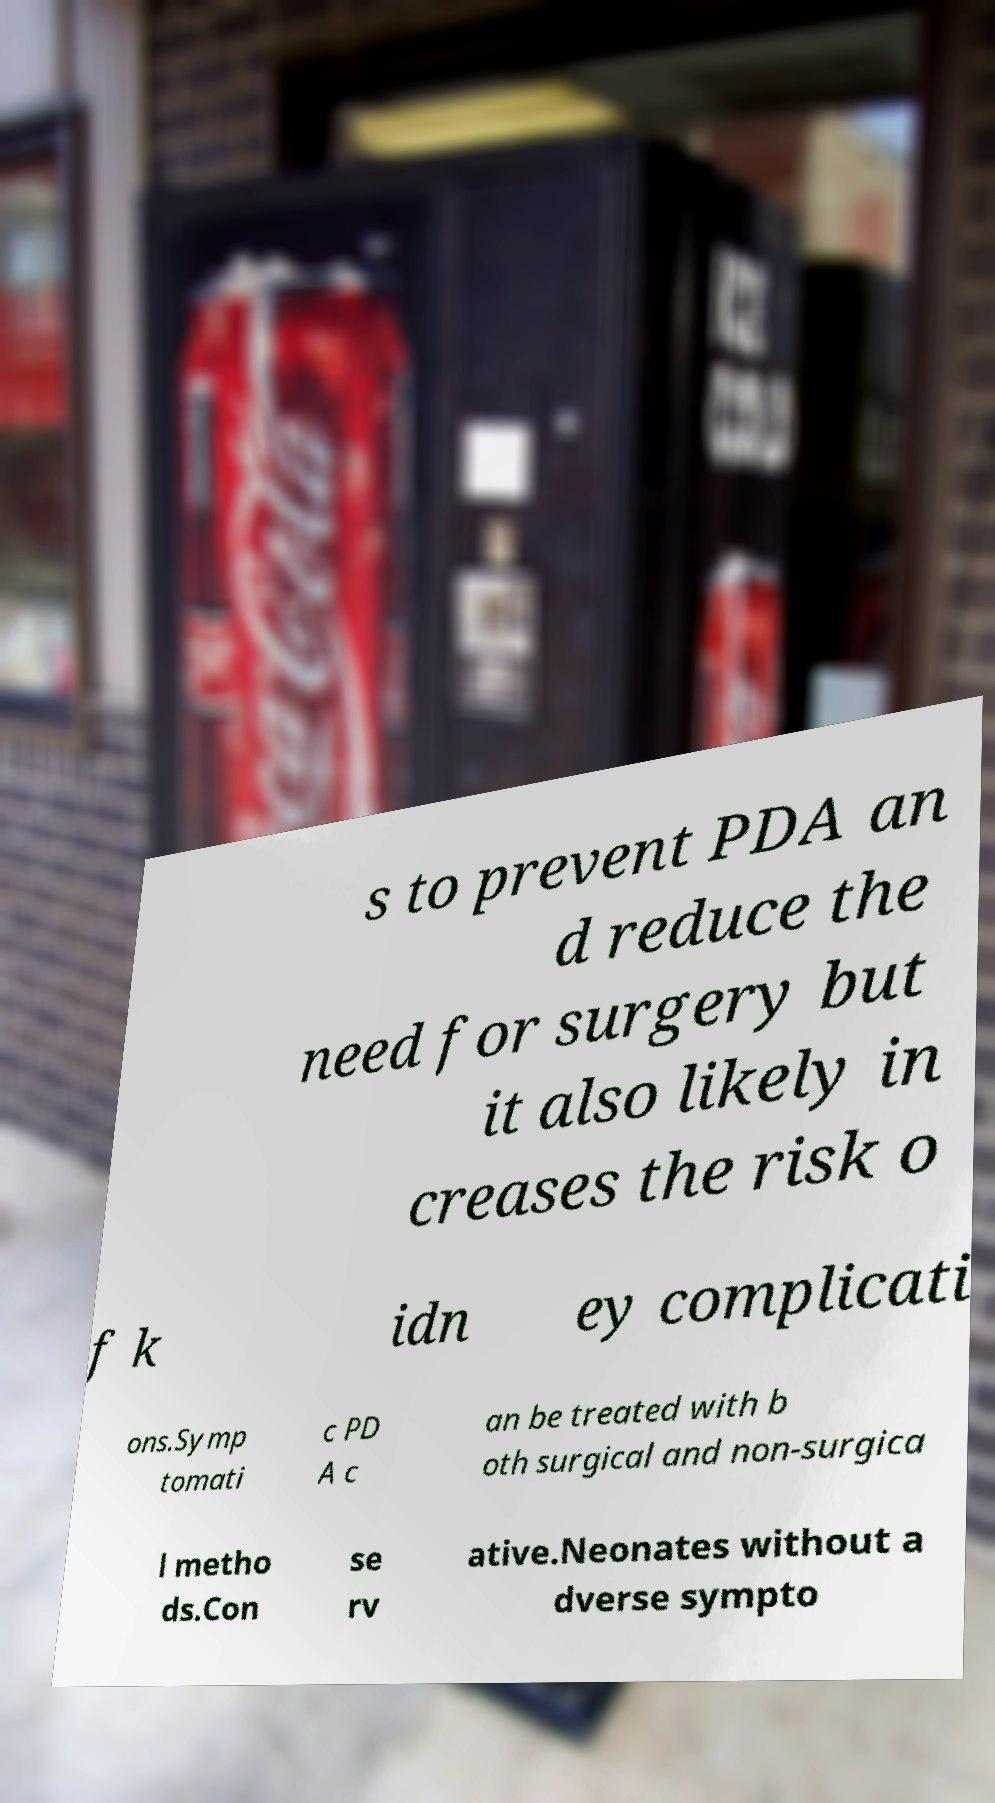Can you read and provide the text displayed in the image?This photo seems to have some interesting text. Can you extract and type it out for me? s to prevent PDA an d reduce the need for surgery but it also likely in creases the risk o f k idn ey complicati ons.Symp tomati c PD A c an be treated with b oth surgical and non-surgica l metho ds.Con se rv ative.Neonates without a dverse sympto 